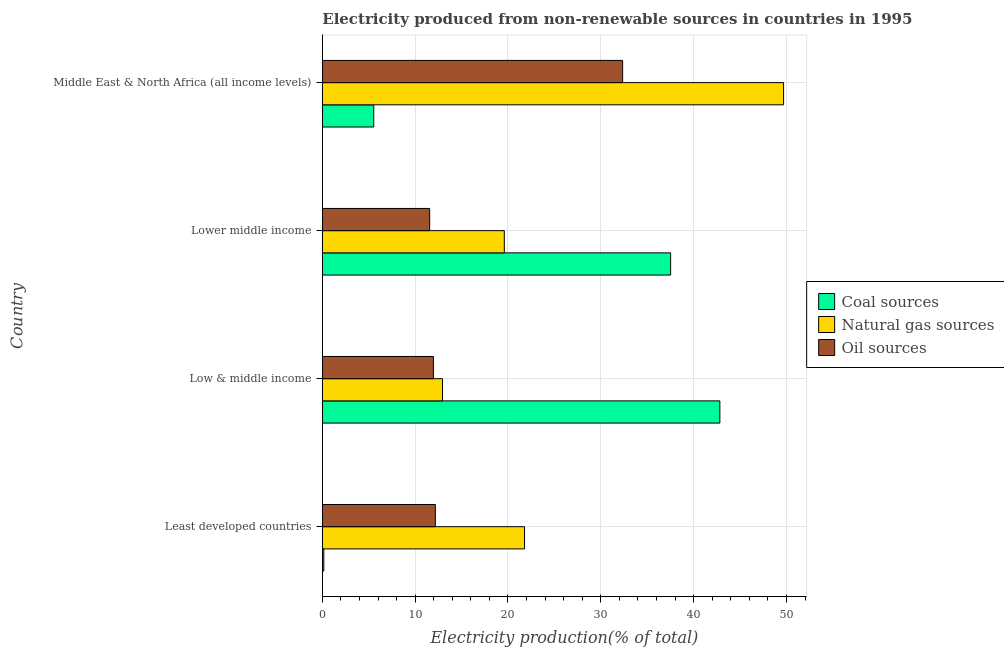How many groups of bars are there?
Give a very brief answer. 4. Are the number of bars on each tick of the Y-axis equal?
Your response must be concise. Yes. How many bars are there on the 3rd tick from the bottom?
Provide a short and direct response. 3. What is the label of the 4th group of bars from the top?
Provide a short and direct response. Least developed countries. What is the percentage of electricity produced by oil sources in Low & middle income?
Give a very brief answer. 11.97. Across all countries, what is the maximum percentage of electricity produced by natural gas?
Provide a succinct answer. 49.69. Across all countries, what is the minimum percentage of electricity produced by natural gas?
Provide a succinct answer. 12.95. What is the total percentage of electricity produced by coal in the graph?
Provide a succinct answer. 86.04. What is the difference between the percentage of electricity produced by natural gas in Low & middle income and that in Lower middle income?
Offer a terse response. -6.66. What is the difference between the percentage of electricity produced by coal in Least developed countries and the percentage of electricity produced by oil sources in Lower middle income?
Provide a succinct answer. -11.4. What is the average percentage of electricity produced by coal per country?
Your response must be concise. 21.51. What is the difference between the percentage of electricity produced by coal and percentage of electricity produced by natural gas in Middle East & North Africa (all income levels)?
Offer a terse response. -44.15. In how many countries, is the percentage of electricity produced by natural gas greater than 28 %?
Your answer should be very brief. 1. What is the ratio of the percentage of electricity produced by coal in Least developed countries to that in Middle East & North Africa (all income levels)?
Your answer should be very brief. 0.03. What is the difference between the highest and the second highest percentage of electricity produced by coal?
Make the answer very short. 5.3. What is the difference between the highest and the lowest percentage of electricity produced by natural gas?
Offer a very short reply. 36.74. Is the sum of the percentage of electricity produced by oil sources in Least developed countries and Low & middle income greater than the maximum percentage of electricity produced by coal across all countries?
Offer a terse response. No. What does the 3rd bar from the top in Least developed countries represents?
Offer a terse response. Coal sources. What does the 1st bar from the bottom in Least developed countries represents?
Offer a very short reply. Coal sources. Is it the case that in every country, the sum of the percentage of electricity produced by coal and percentage of electricity produced by natural gas is greater than the percentage of electricity produced by oil sources?
Offer a very short reply. Yes. What is the difference between two consecutive major ticks on the X-axis?
Your response must be concise. 10. Are the values on the major ticks of X-axis written in scientific E-notation?
Provide a succinct answer. No. What is the title of the graph?
Your answer should be very brief. Electricity produced from non-renewable sources in countries in 1995. Does "Machinery" appear as one of the legend labels in the graph?
Ensure brevity in your answer.  No. What is the label or title of the Y-axis?
Provide a succinct answer. Country. What is the Electricity production(% of total) in Coal sources in Least developed countries?
Provide a succinct answer. 0.16. What is the Electricity production(% of total) of Natural gas sources in Least developed countries?
Give a very brief answer. 21.78. What is the Electricity production(% of total) in Oil sources in Least developed countries?
Provide a short and direct response. 12.17. What is the Electricity production(% of total) in Coal sources in Low & middle income?
Offer a terse response. 42.82. What is the Electricity production(% of total) of Natural gas sources in Low & middle income?
Ensure brevity in your answer.  12.95. What is the Electricity production(% of total) in Oil sources in Low & middle income?
Offer a very short reply. 11.97. What is the Electricity production(% of total) in Coal sources in Lower middle income?
Make the answer very short. 37.52. What is the Electricity production(% of total) of Natural gas sources in Lower middle income?
Ensure brevity in your answer.  19.6. What is the Electricity production(% of total) of Oil sources in Lower middle income?
Offer a terse response. 11.56. What is the Electricity production(% of total) in Coal sources in Middle East & North Africa (all income levels)?
Ensure brevity in your answer.  5.54. What is the Electricity production(% of total) in Natural gas sources in Middle East & North Africa (all income levels)?
Your answer should be compact. 49.69. What is the Electricity production(% of total) in Oil sources in Middle East & North Africa (all income levels)?
Your response must be concise. 32.35. Across all countries, what is the maximum Electricity production(% of total) in Coal sources?
Keep it short and to the point. 42.82. Across all countries, what is the maximum Electricity production(% of total) in Natural gas sources?
Make the answer very short. 49.69. Across all countries, what is the maximum Electricity production(% of total) of Oil sources?
Offer a terse response. 32.35. Across all countries, what is the minimum Electricity production(% of total) of Coal sources?
Keep it short and to the point. 0.16. Across all countries, what is the minimum Electricity production(% of total) of Natural gas sources?
Your answer should be very brief. 12.95. Across all countries, what is the minimum Electricity production(% of total) of Oil sources?
Provide a succinct answer. 11.56. What is the total Electricity production(% of total) of Coal sources in the graph?
Make the answer very short. 86.04. What is the total Electricity production(% of total) of Natural gas sources in the graph?
Provide a short and direct response. 104.02. What is the total Electricity production(% of total) in Oil sources in the graph?
Provide a short and direct response. 68.05. What is the difference between the Electricity production(% of total) in Coal sources in Least developed countries and that in Low & middle income?
Offer a terse response. -42.67. What is the difference between the Electricity production(% of total) of Natural gas sources in Least developed countries and that in Low & middle income?
Keep it short and to the point. 8.84. What is the difference between the Electricity production(% of total) of Oil sources in Least developed countries and that in Low & middle income?
Your response must be concise. 0.21. What is the difference between the Electricity production(% of total) of Coal sources in Least developed countries and that in Lower middle income?
Provide a short and direct response. -37.36. What is the difference between the Electricity production(% of total) of Natural gas sources in Least developed countries and that in Lower middle income?
Offer a terse response. 2.18. What is the difference between the Electricity production(% of total) in Oil sources in Least developed countries and that in Lower middle income?
Your answer should be very brief. 0.61. What is the difference between the Electricity production(% of total) in Coal sources in Least developed countries and that in Middle East & North Africa (all income levels)?
Ensure brevity in your answer.  -5.38. What is the difference between the Electricity production(% of total) of Natural gas sources in Least developed countries and that in Middle East & North Africa (all income levels)?
Make the answer very short. -27.9. What is the difference between the Electricity production(% of total) in Oil sources in Least developed countries and that in Middle East & North Africa (all income levels)?
Provide a succinct answer. -20.17. What is the difference between the Electricity production(% of total) in Coal sources in Low & middle income and that in Lower middle income?
Your answer should be very brief. 5.3. What is the difference between the Electricity production(% of total) of Natural gas sources in Low & middle income and that in Lower middle income?
Your answer should be compact. -6.66. What is the difference between the Electricity production(% of total) in Oil sources in Low & middle income and that in Lower middle income?
Provide a short and direct response. 0.4. What is the difference between the Electricity production(% of total) in Coal sources in Low & middle income and that in Middle East & North Africa (all income levels)?
Provide a short and direct response. 37.29. What is the difference between the Electricity production(% of total) of Natural gas sources in Low & middle income and that in Middle East & North Africa (all income levels)?
Your answer should be compact. -36.74. What is the difference between the Electricity production(% of total) in Oil sources in Low & middle income and that in Middle East & North Africa (all income levels)?
Give a very brief answer. -20.38. What is the difference between the Electricity production(% of total) of Coal sources in Lower middle income and that in Middle East & North Africa (all income levels)?
Provide a short and direct response. 31.98. What is the difference between the Electricity production(% of total) of Natural gas sources in Lower middle income and that in Middle East & North Africa (all income levels)?
Provide a succinct answer. -30.09. What is the difference between the Electricity production(% of total) of Oil sources in Lower middle income and that in Middle East & North Africa (all income levels)?
Offer a very short reply. -20.79. What is the difference between the Electricity production(% of total) in Coal sources in Least developed countries and the Electricity production(% of total) in Natural gas sources in Low & middle income?
Offer a terse response. -12.79. What is the difference between the Electricity production(% of total) of Coal sources in Least developed countries and the Electricity production(% of total) of Oil sources in Low & middle income?
Your answer should be very brief. -11.81. What is the difference between the Electricity production(% of total) of Natural gas sources in Least developed countries and the Electricity production(% of total) of Oil sources in Low & middle income?
Ensure brevity in your answer.  9.82. What is the difference between the Electricity production(% of total) in Coal sources in Least developed countries and the Electricity production(% of total) in Natural gas sources in Lower middle income?
Provide a succinct answer. -19.44. What is the difference between the Electricity production(% of total) of Coal sources in Least developed countries and the Electricity production(% of total) of Oil sources in Lower middle income?
Your answer should be very brief. -11.4. What is the difference between the Electricity production(% of total) in Natural gas sources in Least developed countries and the Electricity production(% of total) in Oil sources in Lower middle income?
Your answer should be compact. 10.22. What is the difference between the Electricity production(% of total) of Coal sources in Least developed countries and the Electricity production(% of total) of Natural gas sources in Middle East & North Africa (all income levels)?
Offer a terse response. -49.53. What is the difference between the Electricity production(% of total) of Coal sources in Least developed countries and the Electricity production(% of total) of Oil sources in Middle East & North Africa (all income levels)?
Ensure brevity in your answer.  -32.19. What is the difference between the Electricity production(% of total) in Natural gas sources in Least developed countries and the Electricity production(% of total) in Oil sources in Middle East & North Africa (all income levels)?
Provide a succinct answer. -10.56. What is the difference between the Electricity production(% of total) in Coal sources in Low & middle income and the Electricity production(% of total) in Natural gas sources in Lower middle income?
Offer a very short reply. 23.22. What is the difference between the Electricity production(% of total) of Coal sources in Low & middle income and the Electricity production(% of total) of Oil sources in Lower middle income?
Provide a short and direct response. 31.26. What is the difference between the Electricity production(% of total) in Natural gas sources in Low & middle income and the Electricity production(% of total) in Oil sources in Lower middle income?
Your response must be concise. 1.38. What is the difference between the Electricity production(% of total) in Coal sources in Low & middle income and the Electricity production(% of total) in Natural gas sources in Middle East & North Africa (all income levels)?
Provide a succinct answer. -6.86. What is the difference between the Electricity production(% of total) of Coal sources in Low & middle income and the Electricity production(% of total) of Oil sources in Middle East & North Africa (all income levels)?
Offer a very short reply. 10.48. What is the difference between the Electricity production(% of total) in Natural gas sources in Low & middle income and the Electricity production(% of total) in Oil sources in Middle East & North Africa (all income levels)?
Offer a terse response. -19.4. What is the difference between the Electricity production(% of total) in Coal sources in Lower middle income and the Electricity production(% of total) in Natural gas sources in Middle East & North Africa (all income levels)?
Give a very brief answer. -12.17. What is the difference between the Electricity production(% of total) in Coal sources in Lower middle income and the Electricity production(% of total) in Oil sources in Middle East & North Africa (all income levels)?
Offer a very short reply. 5.17. What is the difference between the Electricity production(% of total) in Natural gas sources in Lower middle income and the Electricity production(% of total) in Oil sources in Middle East & North Africa (all income levels)?
Your answer should be compact. -12.75. What is the average Electricity production(% of total) in Coal sources per country?
Offer a terse response. 21.51. What is the average Electricity production(% of total) of Natural gas sources per country?
Make the answer very short. 26.01. What is the average Electricity production(% of total) of Oil sources per country?
Provide a short and direct response. 17.01. What is the difference between the Electricity production(% of total) of Coal sources and Electricity production(% of total) of Natural gas sources in Least developed countries?
Offer a terse response. -21.63. What is the difference between the Electricity production(% of total) in Coal sources and Electricity production(% of total) in Oil sources in Least developed countries?
Your answer should be very brief. -12.02. What is the difference between the Electricity production(% of total) in Natural gas sources and Electricity production(% of total) in Oil sources in Least developed countries?
Keep it short and to the point. 9.61. What is the difference between the Electricity production(% of total) of Coal sources and Electricity production(% of total) of Natural gas sources in Low & middle income?
Provide a short and direct response. 29.88. What is the difference between the Electricity production(% of total) of Coal sources and Electricity production(% of total) of Oil sources in Low & middle income?
Your answer should be compact. 30.86. What is the difference between the Electricity production(% of total) of Natural gas sources and Electricity production(% of total) of Oil sources in Low & middle income?
Offer a terse response. 0.98. What is the difference between the Electricity production(% of total) of Coal sources and Electricity production(% of total) of Natural gas sources in Lower middle income?
Offer a very short reply. 17.92. What is the difference between the Electricity production(% of total) of Coal sources and Electricity production(% of total) of Oil sources in Lower middle income?
Ensure brevity in your answer.  25.96. What is the difference between the Electricity production(% of total) of Natural gas sources and Electricity production(% of total) of Oil sources in Lower middle income?
Give a very brief answer. 8.04. What is the difference between the Electricity production(% of total) of Coal sources and Electricity production(% of total) of Natural gas sources in Middle East & North Africa (all income levels)?
Give a very brief answer. -44.15. What is the difference between the Electricity production(% of total) of Coal sources and Electricity production(% of total) of Oil sources in Middle East & North Africa (all income levels)?
Keep it short and to the point. -26.81. What is the difference between the Electricity production(% of total) in Natural gas sources and Electricity production(% of total) in Oil sources in Middle East & North Africa (all income levels)?
Ensure brevity in your answer.  17.34. What is the ratio of the Electricity production(% of total) in Coal sources in Least developed countries to that in Low & middle income?
Your answer should be very brief. 0. What is the ratio of the Electricity production(% of total) of Natural gas sources in Least developed countries to that in Low & middle income?
Your answer should be very brief. 1.68. What is the ratio of the Electricity production(% of total) in Oil sources in Least developed countries to that in Low & middle income?
Ensure brevity in your answer.  1.02. What is the ratio of the Electricity production(% of total) in Coal sources in Least developed countries to that in Lower middle income?
Ensure brevity in your answer.  0. What is the ratio of the Electricity production(% of total) in Natural gas sources in Least developed countries to that in Lower middle income?
Your response must be concise. 1.11. What is the ratio of the Electricity production(% of total) in Oil sources in Least developed countries to that in Lower middle income?
Your answer should be compact. 1.05. What is the ratio of the Electricity production(% of total) of Coal sources in Least developed countries to that in Middle East & North Africa (all income levels)?
Provide a succinct answer. 0.03. What is the ratio of the Electricity production(% of total) of Natural gas sources in Least developed countries to that in Middle East & North Africa (all income levels)?
Keep it short and to the point. 0.44. What is the ratio of the Electricity production(% of total) of Oil sources in Least developed countries to that in Middle East & North Africa (all income levels)?
Your answer should be very brief. 0.38. What is the ratio of the Electricity production(% of total) in Coal sources in Low & middle income to that in Lower middle income?
Make the answer very short. 1.14. What is the ratio of the Electricity production(% of total) of Natural gas sources in Low & middle income to that in Lower middle income?
Offer a very short reply. 0.66. What is the ratio of the Electricity production(% of total) in Oil sources in Low & middle income to that in Lower middle income?
Keep it short and to the point. 1.03. What is the ratio of the Electricity production(% of total) of Coal sources in Low & middle income to that in Middle East & North Africa (all income levels)?
Your response must be concise. 7.73. What is the ratio of the Electricity production(% of total) in Natural gas sources in Low & middle income to that in Middle East & North Africa (all income levels)?
Give a very brief answer. 0.26. What is the ratio of the Electricity production(% of total) in Oil sources in Low & middle income to that in Middle East & North Africa (all income levels)?
Provide a succinct answer. 0.37. What is the ratio of the Electricity production(% of total) in Coal sources in Lower middle income to that in Middle East & North Africa (all income levels)?
Make the answer very short. 6.77. What is the ratio of the Electricity production(% of total) of Natural gas sources in Lower middle income to that in Middle East & North Africa (all income levels)?
Your answer should be compact. 0.39. What is the ratio of the Electricity production(% of total) in Oil sources in Lower middle income to that in Middle East & North Africa (all income levels)?
Your answer should be very brief. 0.36. What is the difference between the highest and the second highest Electricity production(% of total) in Coal sources?
Provide a succinct answer. 5.3. What is the difference between the highest and the second highest Electricity production(% of total) in Natural gas sources?
Your answer should be compact. 27.9. What is the difference between the highest and the second highest Electricity production(% of total) of Oil sources?
Your response must be concise. 20.17. What is the difference between the highest and the lowest Electricity production(% of total) of Coal sources?
Offer a very short reply. 42.67. What is the difference between the highest and the lowest Electricity production(% of total) of Natural gas sources?
Offer a terse response. 36.74. What is the difference between the highest and the lowest Electricity production(% of total) of Oil sources?
Keep it short and to the point. 20.79. 